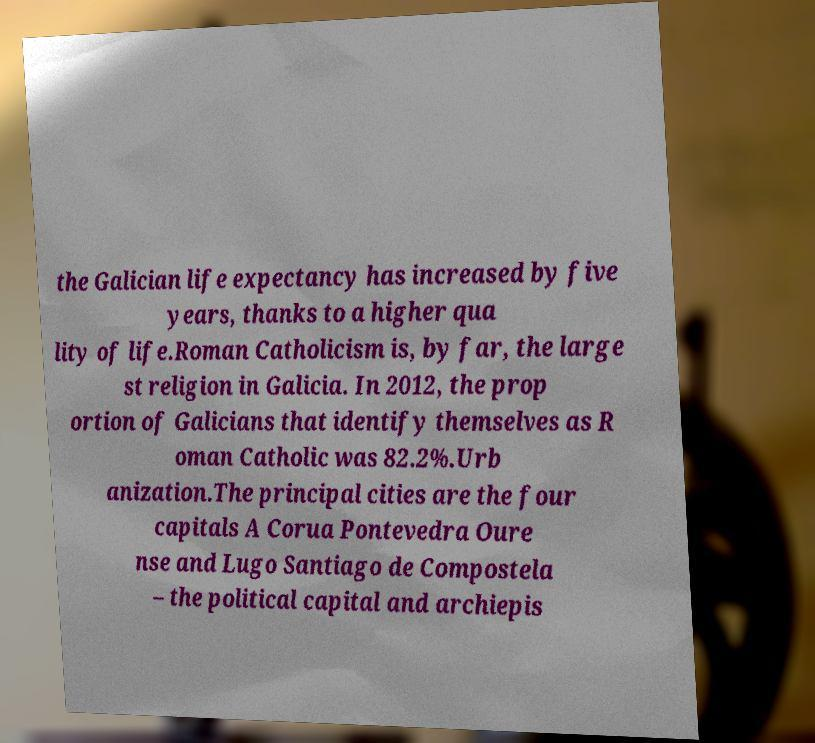What messages or text are displayed in this image? I need them in a readable, typed format. the Galician life expectancy has increased by five years, thanks to a higher qua lity of life.Roman Catholicism is, by far, the large st religion in Galicia. In 2012, the prop ortion of Galicians that identify themselves as R oman Catholic was 82.2%.Urb anization.The principal cities are the four capitals A Corua Pontevedra Oure nse and Lugo Santiago de Compostela – the political capital and archiepis 